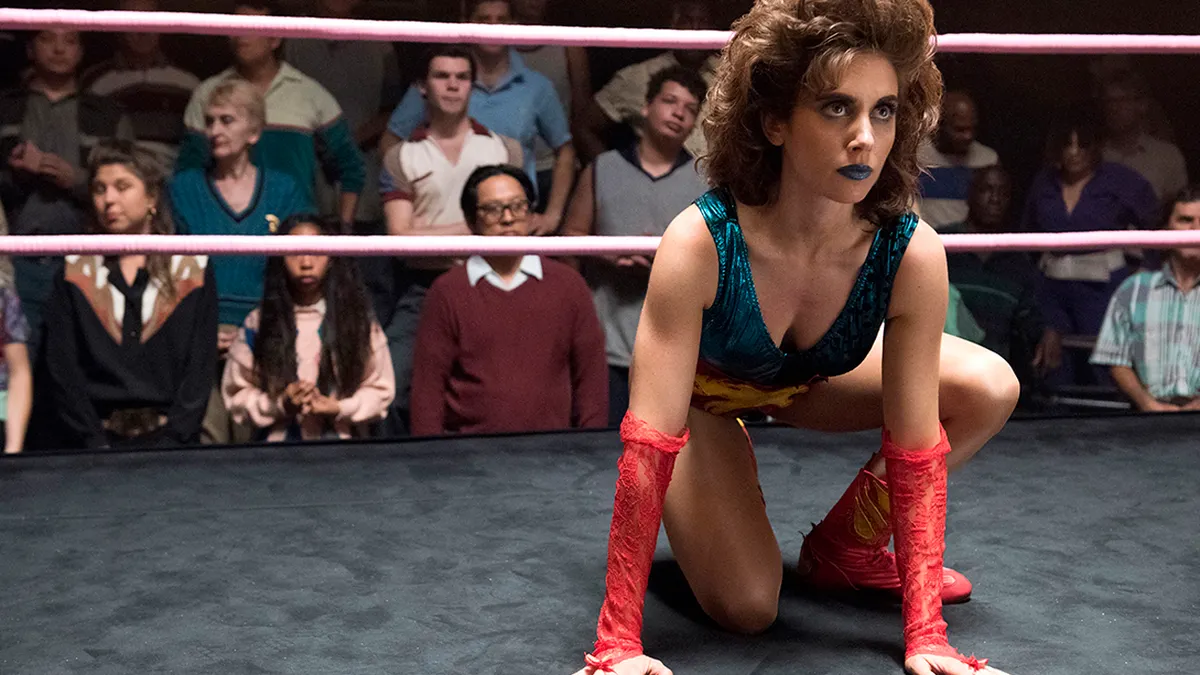What are the key elements in this picture?
 In the image, we see the actress Alison Brie embodying her character Ruth Wilder from the TV show GLOW. She is in the center of a wrestling ring, crouched in a ready stance. Dressed in a vibrant blue and red leotard, she's also wearing matching red gloves. Her hair is styled into a curly updo, adding to her fierce and determined expression. The background is filled with a crowd of spectators, their attention riveted on the wrestling match. 